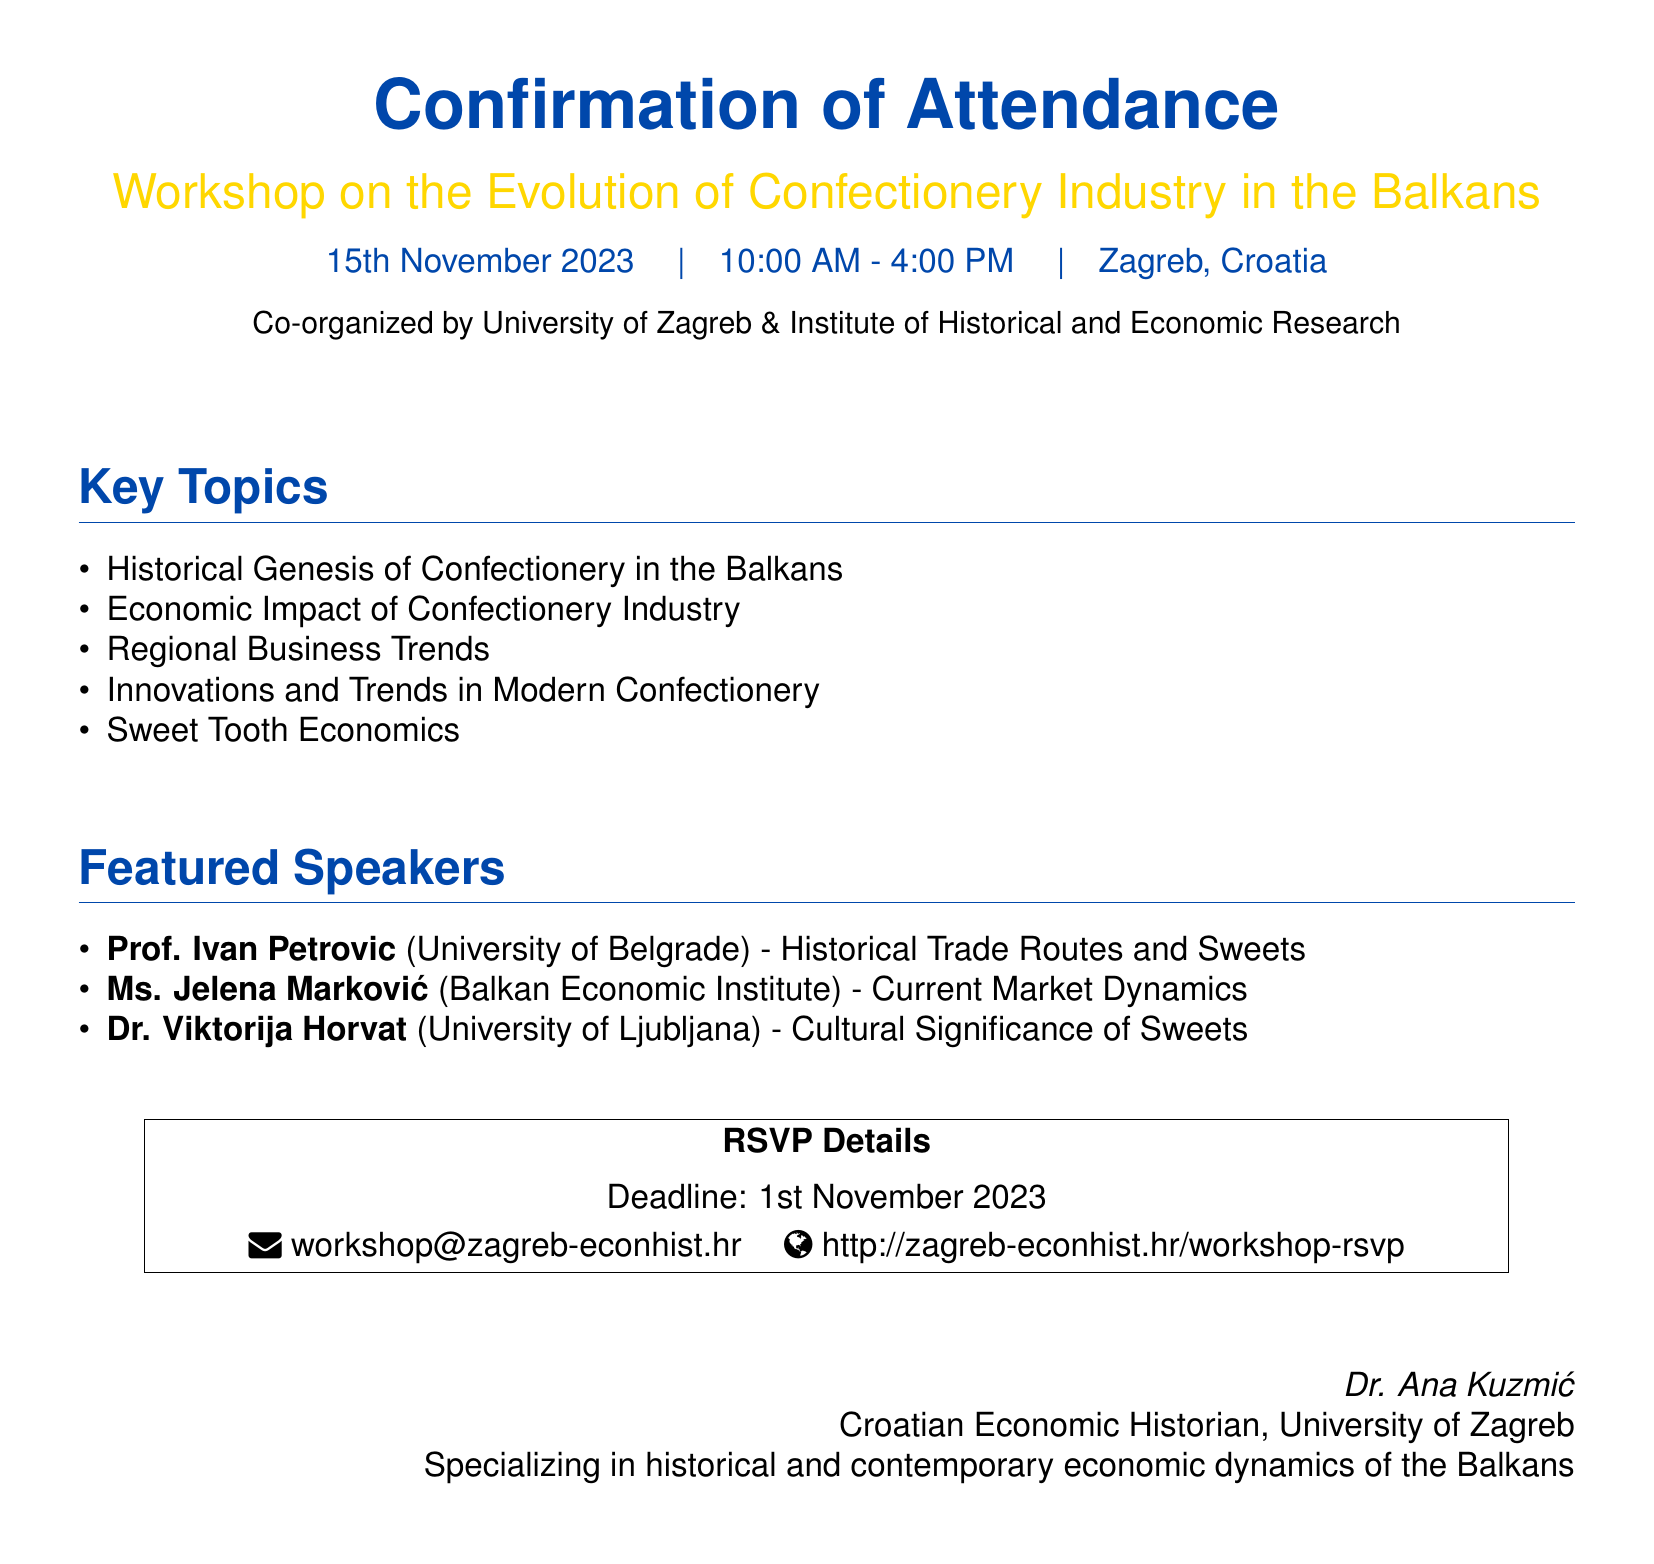What is the date of the workshop? The date of the workshop is explicitly stated in the document.
Answer: 15th November 2023 What time does the workshop start? The starting time for the workshop is listed in the event details.
Answer: 10:00 AM Where is the workshop taking place? The location of the workshop is mentioned in the document.
Answer: Zagreb, Croatia Who is one of the featured speakers? The names of featured speakers are provided in the document.
Answer: Prof. Ivan Petrovic What is the RSVP deadline? The deadline for confirming attendance is specified in the RSVP details section.
Answer: 1st November 2023 Which organization is co-organizing the workshop? The co-organizers of the workshop are mentioned in the document.
Answer: University of Zagreb What is one of the key topics covered in the workshop? The key topics are listed in the document, illustrating the focus areas of the workshop.
Answer: Economic Impact of Confectionery Industry What type of event is this document for? The document is clearly formatted for a specific type of event.
Answer: Workshop 